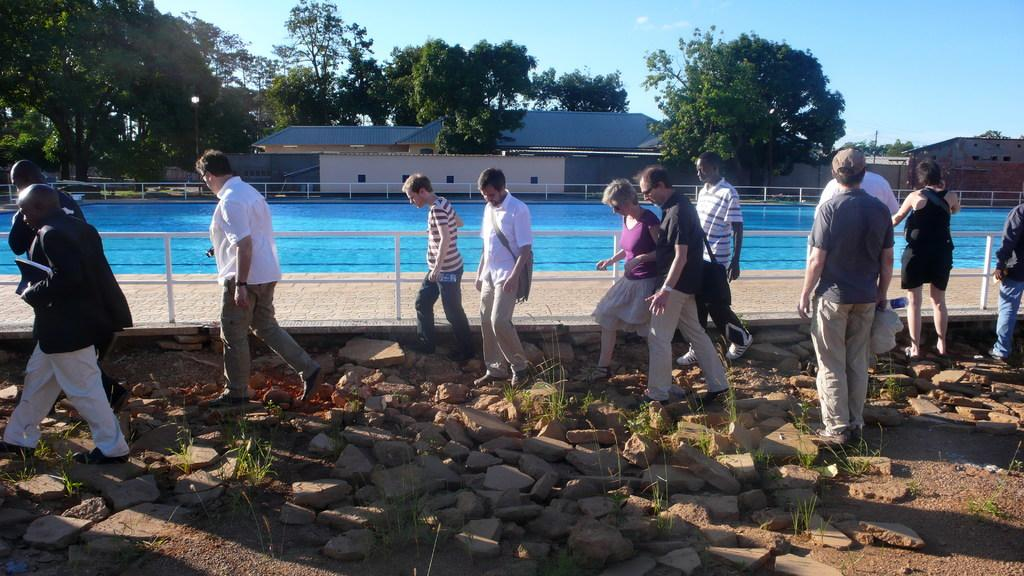What are the people in the image doing? The people in the image are walking. What is on the land in the image? The land has stones on it. What can be seen in the background of the image? There is a pool, houses, trees, and the sky visible in the background of the image. What type of form is being filled out by the people in the image? There is no form present in the image; the people are walking. Can you tell me what is inside the pan that is visible in the image? There is no pan present in the image. 